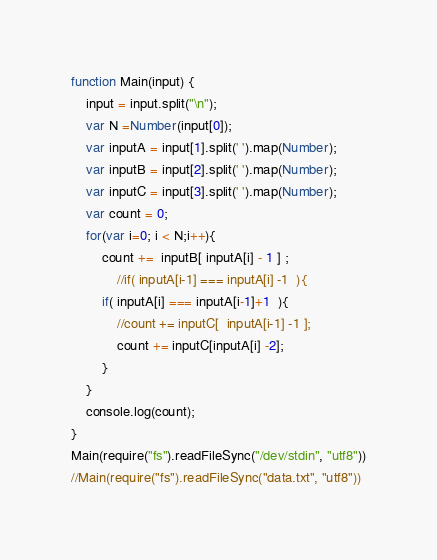Convert code to text. <code><loc_0><loc_0><loc_500><loc_500><_JavaScript_>function Main(input) {
    input = input.split("\n");
    var N =Number(input[0]);
    var inputA = input[1].split(' ').map(Number);
    var inputB = input[2].split(' ').map(Number);
    var inputC = input[3].split(' ').map(Number);
    var count = 0;
    for(var i=0; i < N;i++){
        count +=  inputB[ inputA[i] - 1 ] ;
            //if( inputA[i-1] === inputA[i] -1  ){
        if( inputA[i] === inputA[i-1]+1  ){
            //count += inputC[  inputA[i-1] -1 ];
            count += inputC[inputA[i] -2];
        }
    }
    console.log(count);
}
Main(require("fs").readFileSync("/dev/stdin", "utf8"))
//Main(require("fs").readFileSync("data.txt", "utf8"))</code> 